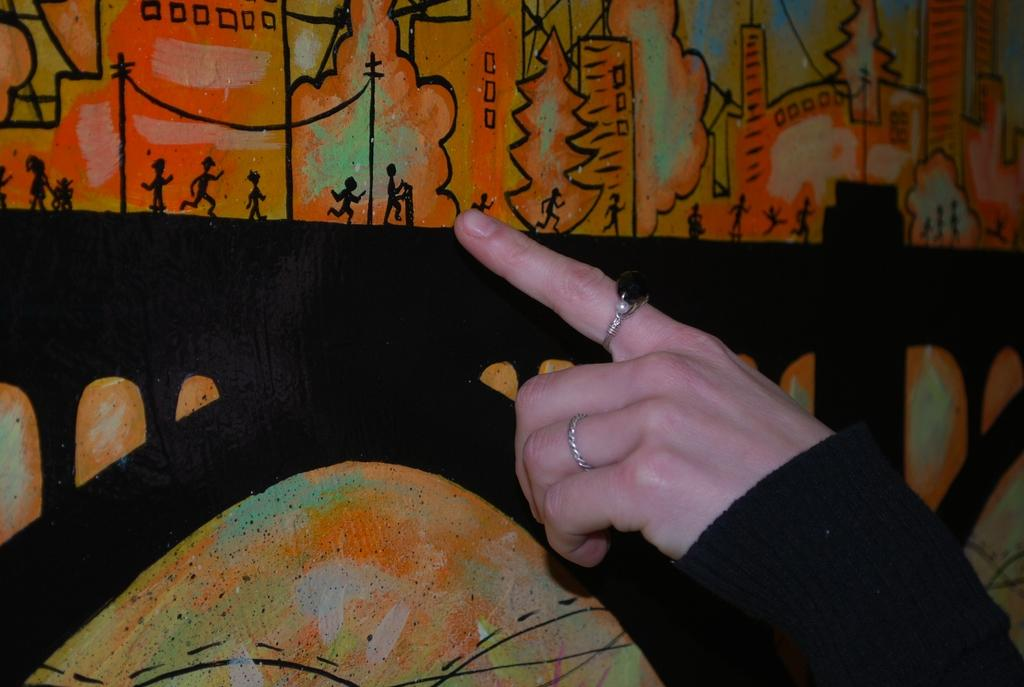What part of a person's body is visible in the image? There is a person's hand in the image. What can be seen in the background of the image? There is a wall in the background of the image. What type of machine is being operated by the person's hand in the image? There is no machine present in the image; only a person's hand and a wall are visible. 